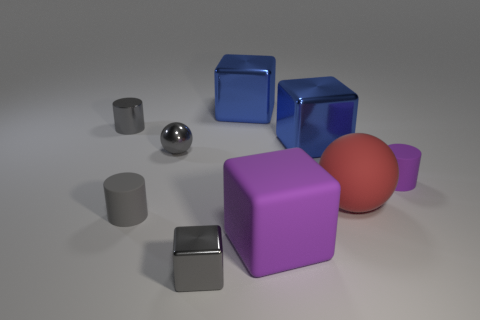Subtract all spheres. How many objects are left? 7 Subtract 0 cyan spheres. How many objects are left? 9 Subtract all gray metallic things. Subtract all tiny purple cylinders. How many objects are left? 5 Add 7 spheres. How many spheres are left? 9 Add 7 purple cubes. How many purple cubes exist? 8 